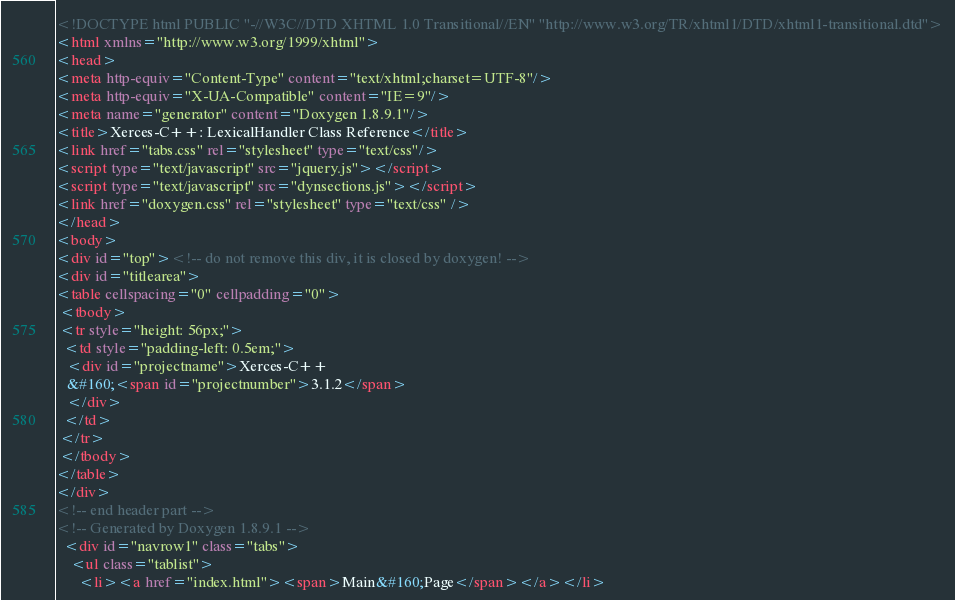Convert code to text. <code><loc_0><loc_0><loc_500><loc_500><_HTML_><!DOCTYPE html PUBLIC "-//W3C//DTD XHTML 1.0 Transitional//EN" "http://www.w3.org/TR/xhtml1/DTD/xhtml1-transitional.dtd">
<html xmlns="http://www.w3.org/1999/xhtml">
<head>
<meta http-equiv="Content-Type" content="text/xhtml;charset=UTF-8"/>
<meta http-equiv="X-UA-Compatible" content="IE=9"/>
<meta name="generator" content="Doxygen 1.8.9.1"/>
<title>Xerces-C++: LexicalHandler Class Reference</title>
<link href="tabs.css" rel="stylesheet" type="text/css"/>
<script type="text/javascript" src="jquery.js"></script>
<script type="text/javascript" src="dynsections.js"></script>
<link href="doxygen.css" rel="stylesheet" type="text/css" />
</head>
<body>
<div id="top"><!-- do not remove this div, it is closed by doxygen! -->
<div id="titlearea">
<table cellspacing="0" cellpadding="0">
 <tbody>
 <tr style="height: 56px;">
  <td style="padding-left: 0.5em;">
   <div id="projectname">Xerces-C++
   &#160;<span id="projectnumber">3.1.2</span>
   </div>
  </td>
 </tr>
 </tbody>
</table>
</div>
<!-- end header part -->
<!-- Generated by Doxygen 1.8.9.1 -->
  <div id="navrow1" class="tabs">
    <ul class="tablist">
      <li><a href="index.html"><span>Main&#160;Page</span></a></li></code> 